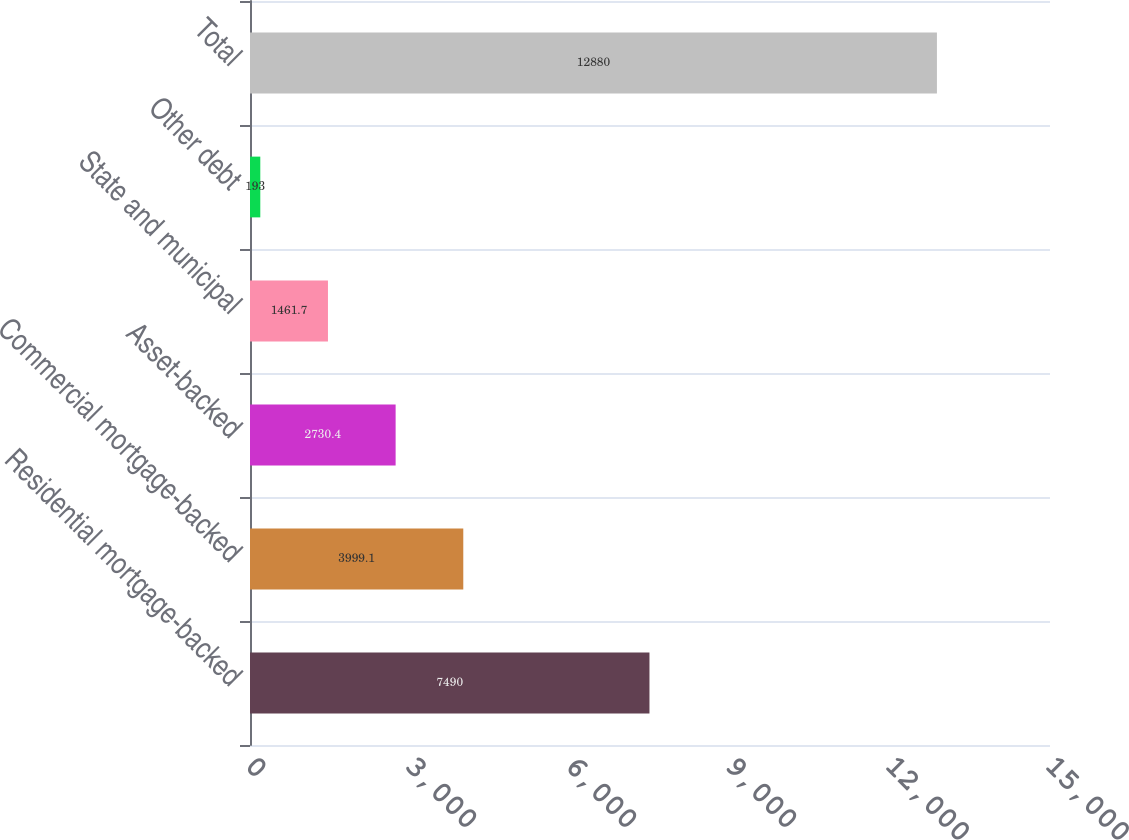Convert chart to OTSL. <chart><loc_0><loc_0><loc_500><loc_500><bar_chart><fcel>Residential mortgage-backed<fcel>Commercial mortgage-backed<fcel>Asset-backed<fcel>State and municipal<fcel>Other debt<fcel>Total<nl><fcel>7490<fcel>3999.1<fcel>2730.4<fcel>1461.7<fcel>193<fcel>12880<nl></chart> 